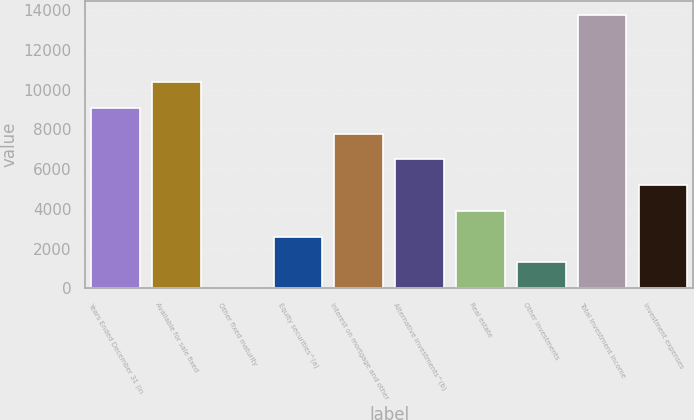Convert chart to OTSL. <chart><loc_0><loc_0><loc_500><loc_500><bar_chart><fcel>Years Ended December 31 (in<fcel>Available for sale fixed<fcel>Other fixed maturity<fcel>Equity securities^(a)<fcel>Interest on mortgage and other<fcel>Alternative investments^(b)<fcel>Real estate<fcel>Other investments<fcel>Total investment income<fcel>Investment expenses<nl><fcel>9080.4<fcel>10376.6<fcel>7<fcel>2599.4<fcel>7784.2<fcel>6488<fcel>3895.6<fcel>1303.2<fcel>13772.2<fcel>5191.8<nl></chart> 